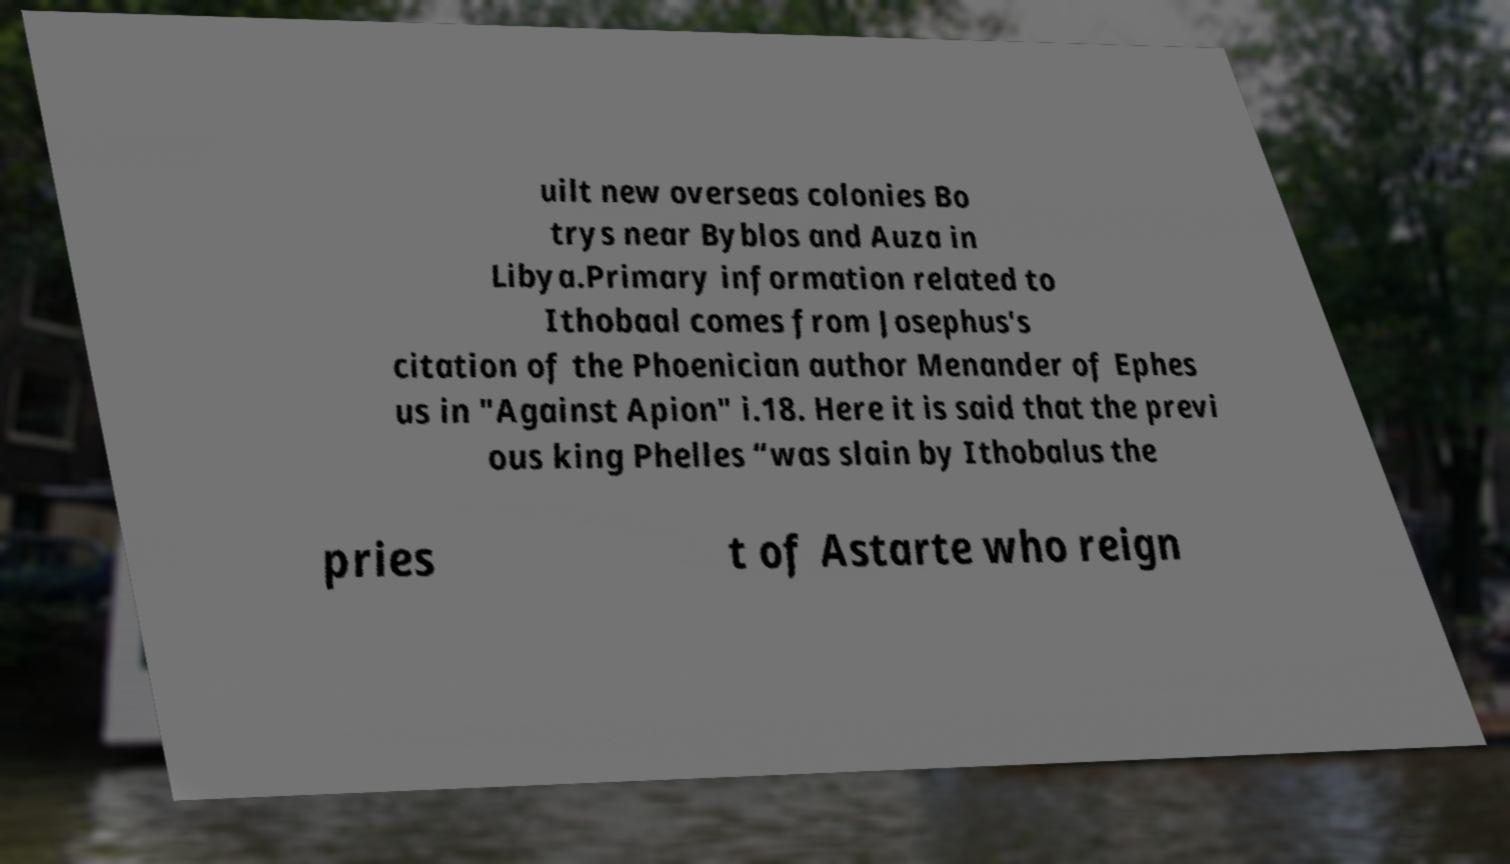There's text embedded in this image that I need extracted. Can you transcribe it verbatim? uilt new overseas colonies Bo trys near Byblos and Auza in Libya.Primary information related to Ithobaal comes from Josephus's citation of the Phoenician author Menander of Ephes us in "Against Apion" i.18. Here it is said that the previ ous king Phelles “was slain by Ithobalus the pries t of Astarte who reign 